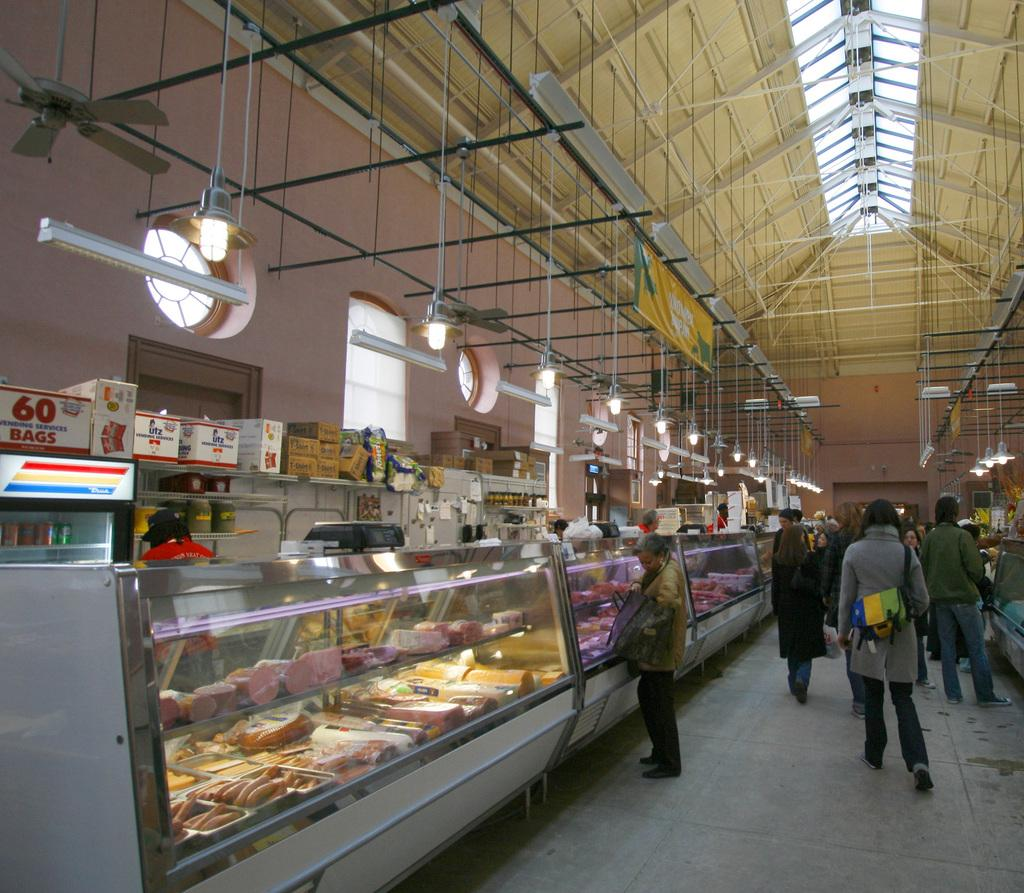Provide a one-sentence caption for the provided image. 60 bags box on top of a freezer in a market. 